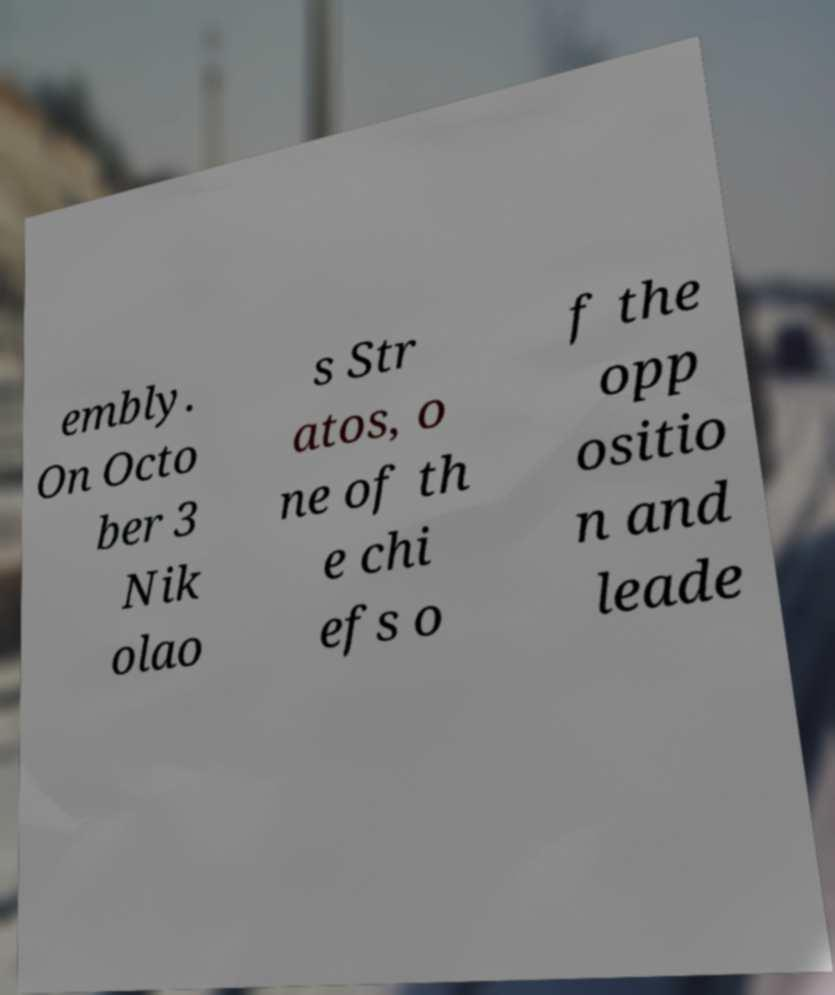Can you read and provide the text displayed in the image?This photo seems to have some interesting text. Can you extract and type it out for me? embly. On Octo ber 3 Nik olao s Str atos, o ne of th e chi efs o f the opp ositio n and leade 